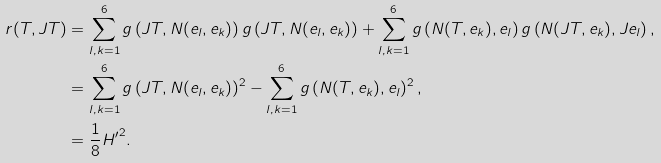<formula> <loc_0><loc_0><loc_500><loc_500>r ( T , J T ) & = \sum _ { l , k = 1 } ^ { 6 } g \left ( J T , N ( e _ { l } , e _ { k } ) \right ) g \left ( J T , N ( e _ { l } , e _ { k } ) \right ) + \sum _ { l , k = 1 } ^ { 6 } g \left ( N ( T , e _ { k } ) , e _ { l } \right ) g \left ( N ( J T , e _ { k } ) , J e _ { l } \right ) , \\ & = \sum _ { l , k = 1 } ^ { 6 } g \left ( J T , N ( e _ { l } , e _ { k } ) \right ) ^ { 2 } - \sum _ { l , k = 1 } ^ { 6 } g \left ( N ( T , e _ { k } ) , e _ { l } \right ) ^ { 2 } , \\ & = \frac { 1 } { 8 } { H ^ { \prime } } ^ { 2 } .</formula> 